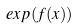Convert formula to latex. <formula><loc_0><loc_0><loc_500><loc_500>e x p ( f ( x ) )</formula> 